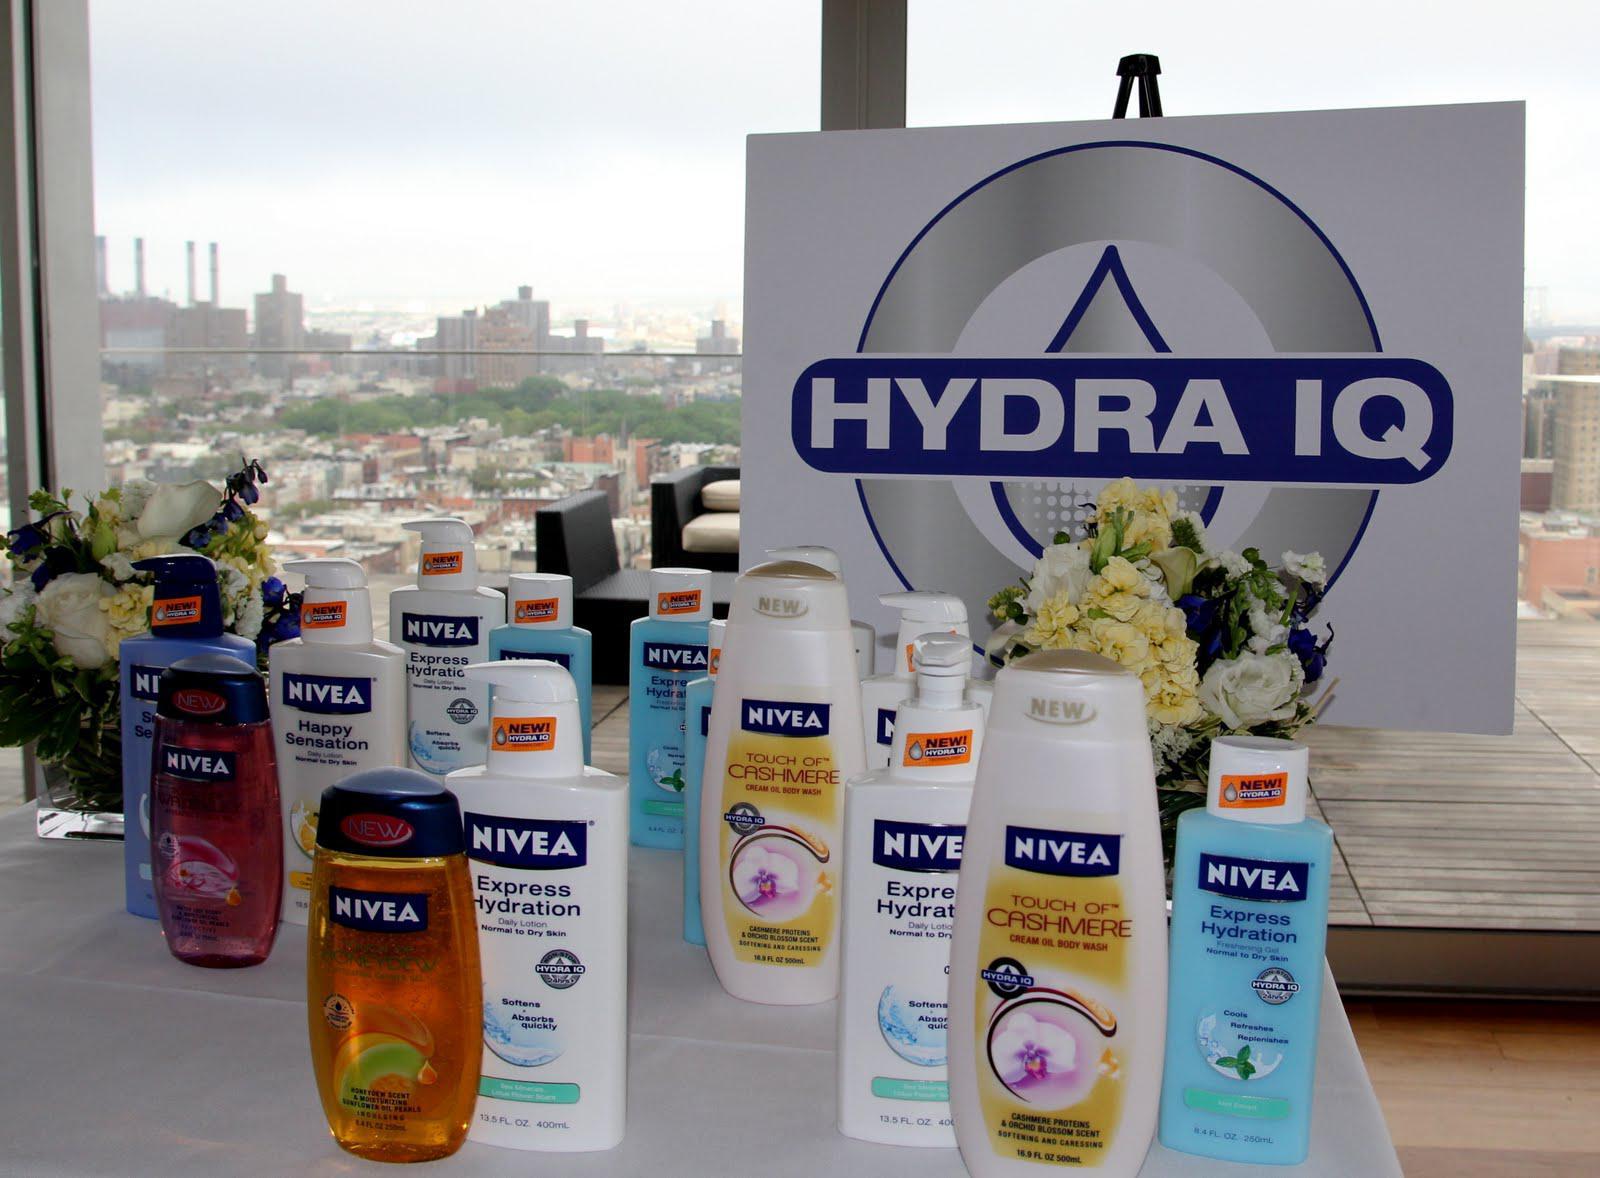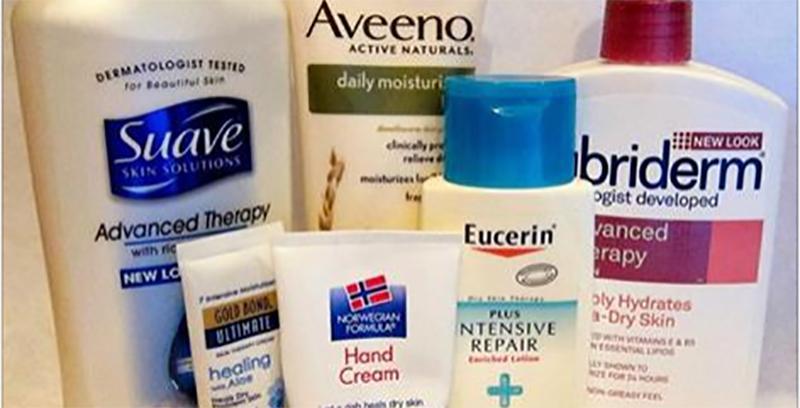The first image is the image on the left, the second image is the image on the right. Examine the images to the left and right. Is the description "Three containers are shown in one of the images." accurate? Answer yes or no. No. The first image is the image on the left, the second image is the image on the right. Evaluate the accuracy of this statement regarding the images: "One image shows exactly three skincare products, which are in a row and upright.". Is it true? Answer yes or no. No. 